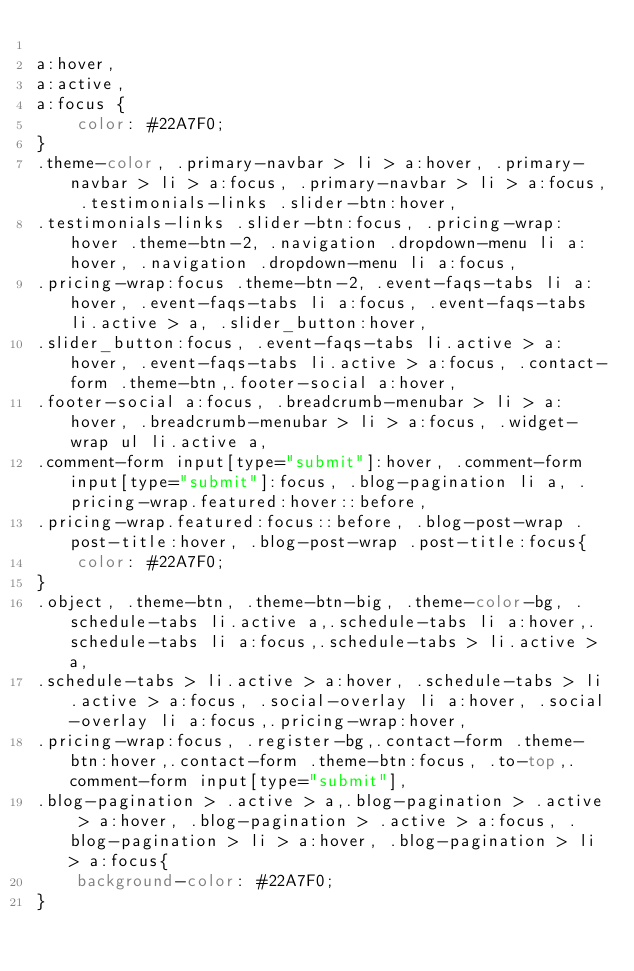Convert code to text. <code><loc_0><loc_0><loc_500><loc_500><_CSS_>
a:hover,
a:active,
a:focus {
    color: #22A7F0;
}
.theme-color, .primary-navbar > li > a:hover, .primary-navbar > li > a:focus, .primary-navbar > li > a:focus, .testimonials-links .slider-btn:hover,
.testimonials-links .slider-btn:focus, .pricing-wrap:hover .theme-btn-2, .navigation .dropdown-menu li a:hover, .navigation .dropdown-menu li a:focus, 
.pricing-wrap:focus .theme-btn-2, .event-faqs-tabs li a:hover, .event-faqs-tabs li a:focus, .event-faqs-tabs li.active > a, .slider_button:hover,
.slider_button:focus, .event-faqs-tabs li.active > a:hover, .event-faqs-tabs li.active > a:focus, .contact-form .theme-btn,.footer-social a:hover, 
.footer-social a:focus, .breadcrumb-menubar > li > a:hover, .breadcrumb-menubar > li > a:focus, .widget-wrap ul li.active a, 
.comment-form input[type="submit"]:hover, .comment-form input[type="submit"]:focus, .blog-pagination li a, .pricing-wrap.featured:hover::before, 
.pricing-wrap.featured:focus::before, .blog-post-wrap .post-title:hover, .blog-post-wrap .post-title:focus{
    color: #22A7F0; 
}
.object, .theme-btn, .theme-btn-big, .theme-color-bg, .schedule-tabs li.active a,.schedule-tabs li a:hover,.schedule-tabs li a:focus,.schedule-tabs > li.active > a,
.schedule-tabs > li.active > a:hover, .schedule-tabs > li.active > a:focus, .social-overlay li a:hover, .social-overlay li a:focus,.pricing-wrap:hover,
.pricing-wrap:focus, .register-bg,.contact-form .theme-btn:hover,.contact-form .theme-btn:focus, .to-top,.comment-form input[type="submit"],
.blog-pagination > .active > a,.blog-pagination > .active > a:hover, .blog-pagination > .active > a:focus, .blog-pagination > li > a:hover, .blog-pagination > li > a:focus{
    background-color: #22A7F0;
}</code> 